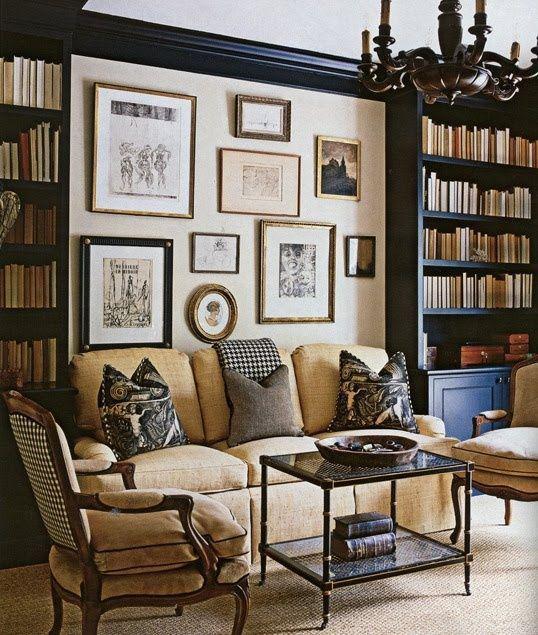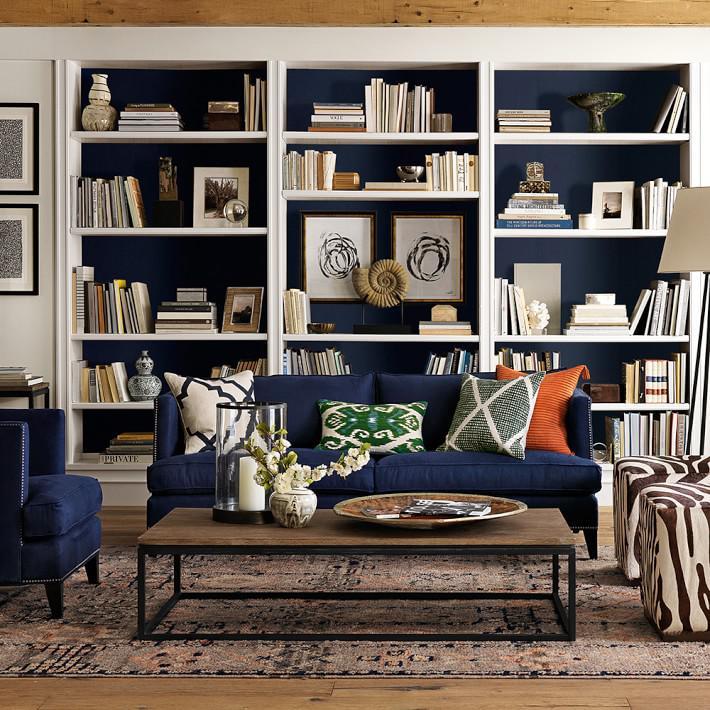The first image is the image on the left, the second image is the image on the right. Analyze the images presented: Is the assertion "There are two lamps with pale shades mounted on the wall behind the couch in one of the images." valid? Answer yes or no. No. The first image is the image on the left, the second image is the image on the right. Examine the images to the left and right. Is the description "in the left image there is a tall window near a book case" accurate? Answer yes or no. No. 